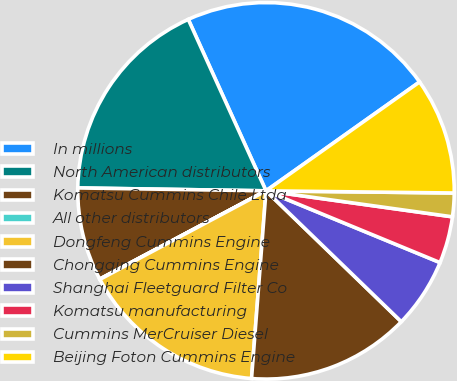Convert chart. <chart><loc_0><loc_0><loc_500><loc_500><pie_chart><fcel>In millions<fcel>North American distributors<fcel>Komatsu Cummins Chile Ltda<fcel>All other distributors<fcel>Dongfeng Cummins Engine<fcel>Chongqing Cummins Engine<fcel>Shanghai Fleetguard Filter Co<fcel>Komatsu manufacturing<fcel>Cummins MerCruiser Diesel<fcel>Beijing Foton Cummins Engine<nl><fcel>21.96%<fcel>17.98%<fcel>8.01%<fcel>0.03%<fcel>15.98%<fcel>13.99%<fcel>6.01%<fcel>4.02%<fcel>2.02%<fcel>10.0%<nl></chart> 